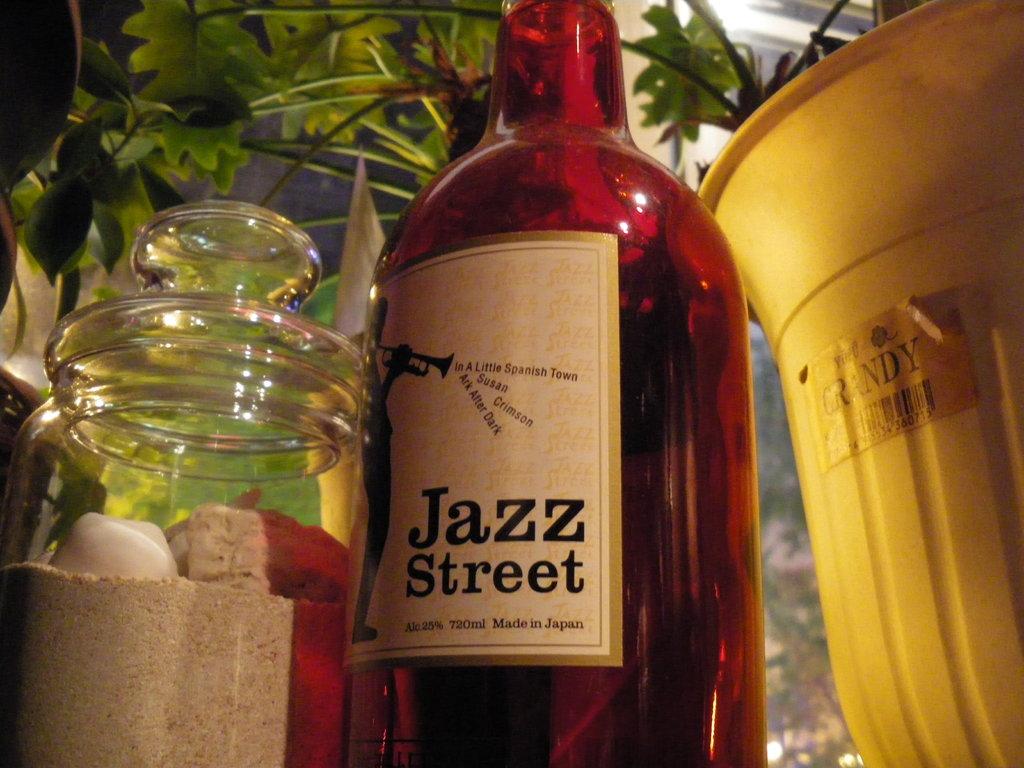What is this drink called?
Offer a very short reply. Jazz street. 